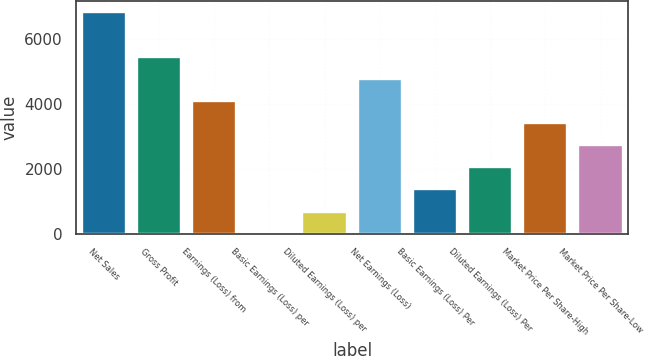Convert chart to OTSL. <chart><loc_0><loc_0><loc_500><loc_500><bar_chart><fcel>Net Sales<fcel>Gross Profit<fcel>Earnings (Loss) from<fcel>Basic Earnings (Loss) per<fcel>Diluted Earnings (Loss) per<fcel>Net Earnings (Loss)<fcel>Basic Earnings (Loss) Per<fcel>Diluted Earnings (Loss) Per<fcel>Market Price Per Share-High<fcel>Market Price Per Share-Low<nl><fcel>6829<fcel>5463.28<fcel>4097.54<fcel>0.32<fcel>683.19<fcel>4780.41<fcel>1366.06<fcel>2048.93<fcel>3414.67<fcel>2731.8<nl></chart> 